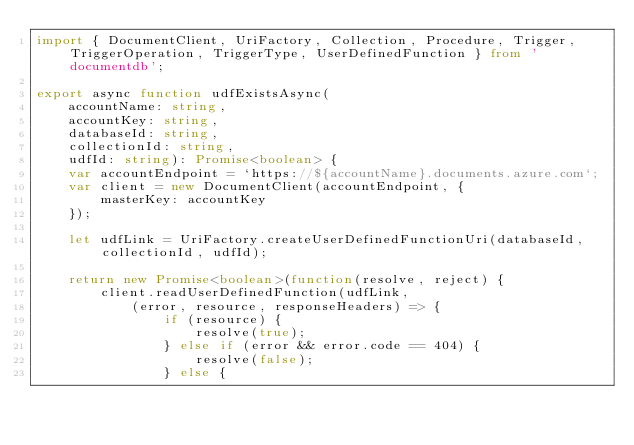Convert code to text. <code><loc_0><loc_0><loc_500><loc_500><_TypeScript_>import { DocumentClient, UriFactory, Collection, Procedure, Trigger, TriggerOperation, TriggerType, UserDefinedFunction } from 'documentdb';

export async function udfExistsAsync(
    accountName: string,
    accountKey: string, 
    databaseId: string,
    collectionId: string,
    udfId: string): Promise<boolean> {
    var accountEndpoint = `https://${accountName}.documents.azure.com`;
    var client = new DocumentClient(accountEndpoint, {
        masterKey: accountKey
    });

    let udfLink = UriFactory.createUserDefinedFunctionUri(databaseId, collectionId, udfId);

    return new Promise<boolean>(function(resolve, reject) {
        client.readUserDefinedFunction(udfLink, 
            (error, resource, responseHeaders) => {
                if (resource) {
                    resolve(true);
                } else if (error && error.code == 404) {
                    resolve(false);
                } else {</code> 